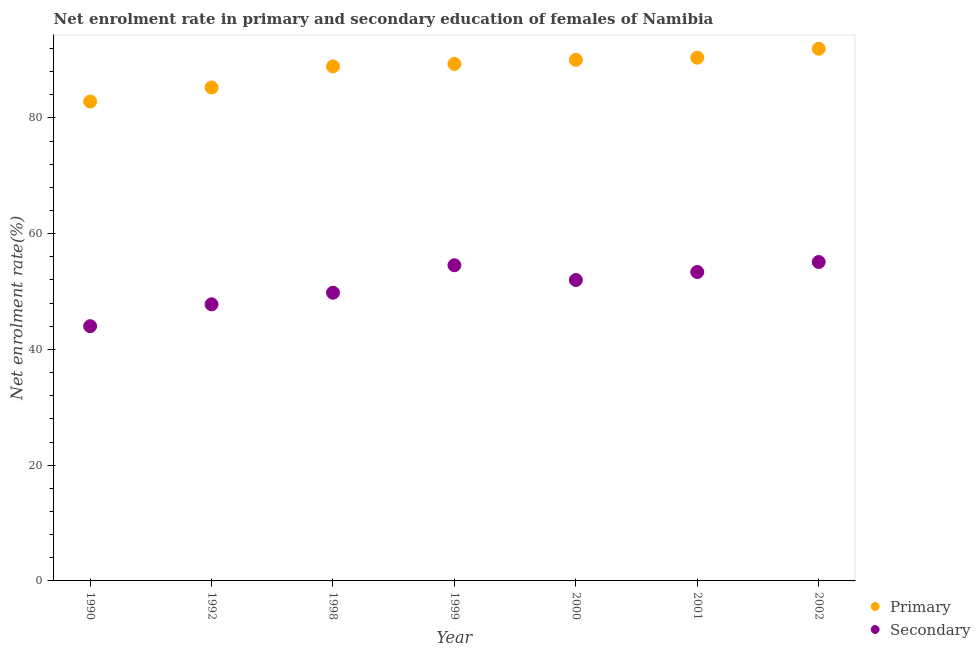How many different coloured dotlines are there?
Keep it short and to the point. 2. Is the number of dotlines equal to the number of legend labels?
Offer a terse response. Yes. What is the enrollment rate in secondary education in 2000?
Offer a terse response. 51.99. Across all years, what is the maximum enrollment rate in secondary education?
Your answer should be very brief. 55.1. Across all years, what is the minimum enrollment rate in secondary education?
Offer a very short reply. 44.01. In which year was the enrollment rate in primary education minimum?
Your answer should be very brief. 1990. What is the total enrollment rate in secondary education in the graph?
Offer a very short reply. 356.61. What is the difference between the enrollment rate in primary education in 1998 and that in 2001?
Make the answer very short. -1.5. What is the difference between the enrollment rate in secondary education in 1999 and the enrollment rate in primary education in 1998?
Provide a succinct answer. -34.35. What is the average enrollment rate in primary education per year?
Offer a very short reply. 88.38. In the year 1990, what is the difference between the enrollment rate in secondary education and enrollment rate in primary education?
Keep it short and to the point. -38.82. In how many years, is the enrollment rate in secondary education greater than 24 %?
Make the answer very short. 7. What is the ratio of the enrollment rate in secondary education in 2001 to that in 2002?
Ensure brevity in your answer.  0.97. Is the enrollment rate in secondary education in 1990 less than that in 2000?
Keep it short and to the point. Yes. Is the difference between the enrollment rate in secondary education in 2000 and 2001 greater than the difference between the enrollment rate in primary education in 2000 and 2001?
Ensure brevity in your answer.  No. What is the difference between the highest and the second highest enrollment rate in secondary education?
Make the answer very short. 0.56. What is the difference between the highest and the lowest enrollment rate in secondary education?
Your answer should be compact. 11.09. Does the enrollment rate in secondary education monotonically increase over the years?
Provide a succinct answer. No. How many dotlines are there?
Provide a short and direct response. 2. How many years are there in the graph?
Ensure brevity in your answer.  7. What is the difference between two consecutive major ticks on the Y-axis?
Provide a succinct answer. 20. Are the values on the major ticks of Y-axis written in scientific E-notation?
Offer a terse response. No. Does the graph contain grids?
Your answer should be compact. No. Where does the legend appear in the graph?
Your answer should be compact. Bottom right. How many legend labels are there?
Make the answer very short. 2. What is the title of the graph?
Give a very brief answer. Net enrolment rate in primary and secondary education of females of Namibia. What is the label or title of the X-axis?
Offer a terse response. Year. What is the label or title of the Y-axis?
Your response must be concise. Net enrolment rate(%). What is the Net enrolment rate(%) of Primary in 1990?
Offer a very short reply. 82.83. What is the Net enrolment rate(%) of Secondary in 1990?
Your response must be concise. 44.01. What is the Net enrolment rate(%) of Primary in 1992?
Offer a very short reply. 85.25. What is the Net enrolment rate(%) of Secondary in 1992?
Keep it short and to the point. 47.79. What is the Net enrolment rate(%) of Primary in 1998?
Provide a short and direct response. 88.89. What is the Net enrolment rate(%) in Secondary in 1998?
Provide a succinct answer. 49.79. What is the Net enrolment rate(%) in Primary in 1999?
Your answer should be compact. 89.32. What is the Net enrolment rate(%) of Secondary in 1999?
Provide a short and direct response. 54.54. What is the Net enrolment rate(%) in Primary in 2000?
Provide a short and direct response. 90.03. What is the Net enrolment rate(%) in Secondary in 2000?
Make the answer very short. 51.99. What is the Net enrolment rate(%) of Primary in 2001?
Your answer should be compact. 90.4. What is the Net enrolment rate(%) of Secondary in 2001?
Provide a short and direct response. 53.37. What is the Net enrolment rate(%) of Primary in 2002?
Ensure brevity in your answer.  91.94. What is the Net enrolment rate(%) of Secondary in 2002?
Give a very brief answer. 55.1. Across all years, what is the maximum Net enrolment rate(%) of Primary?
Make the answer very short. 91.94. Across all years, what is the maximum Net enrolment rate(%) in Secondary?
Offer a very short reply. 55.1. Across all years, what is the minimum Net enrolment rate(%) of Primary?
Your answer should be compact. 82.83. Across all years, what is the minimum Net enrolment rate(%) of Secondary?
Offer a very short reply. 44.01. What is the total Net enrolment rate(%) of Primary in the graph?
Your answer should be very brief. 618.66. What is the total Net enrolment rate(%) in Secondary in the graph?
Your answer should be very brief. 356.61. What is the difference between the Net enrolment rate(%) of Primary in 1990 and that in 1992?
Your answer should be very brief. -2.42. What is the difference between the Net enrolment rate(%) in Secondary in 1990 and that in 1992?
Make the answer very short. -3.78. What is the difference between the Net enrolment rate(%) of Primary in 1990 and that in 1998?
Provide a succinct answer. -6.06. What is the difference between the Net enrolment rate(%) of Secondary in 1990 and that in 1998?
Provide a short and direct response. -5.78. What is the difference between the Net enrolment rate(%) in Primary in 1990 and that in 1999?
Provide a succinct answer. -6.49. What is the difference between the Net enrolment rate(%) of Secondary in 1990 and that in 1999?
Your answer should be very brief. -10.53. What is the difference between the Net enrolment rate(%) of Primary in 1990 and that in 2000?
Give a very brief answer. -7.2. What is the difference between the Net enrolment rate(%) of Secondary in 1990 and that in 2000?
Ensure brevity in your answer.  -7.98. What is the difference between the Net enrolment rate(%) of Primary in 1990 and that in 2001?
Your response must be concise. -7.57. What is the difference between the Net enrolment rate(%) of Secondary in 1990 and that in 2001?
Offer a very short reply. -9.36. What is the difference between the Net enrolment rate(%) of Primary in 1990 and that in 2002?
Provide a succinct answer. -9.12. What is the difference between the Net enrolment rate(%) in Secondary in 1990 and that in 2002?
Make the answer very short. -11.09. What is the difference between the Net enrolment rate(%) of Primary in 1992 and that in 1998?
Provide a succinct answer. -3.64. What is the difference between the Net enrolment rate(%) in Secondary in 1992 and that in 1998?
Your answer should be very brief. -2. What is the difference between the Net enrolment rate(%) in Primary in 1992 and that in 1999?
Provide a short and direct response. -4.07. What is the difference between the Net enrolment rate(%) of Secondary in 1992 and that in 1999?
Your response must be concise. -6.75. What is the difference between the Net enrolment rate(%) in Primary in 1992 and that in 2000?
Offer a terse response. -4.78. What is the difference between the Net enrolment rate(%) of Secondary in 1992 and that in 2000?
Give a very brief answer. -4.2. What is the difference between the Net enrolment rate(%) of Primary in 1992 and that in 2001?
Offer a very short reply. -5.15. What is the difference between the Net enrolment rate(%) of Secondary in 1992 and that in 2001?
Your response must be concise. -5.58. What is the difference between the Net enrolment rate(%) of Primary in 1992 and that in 2002?
Ensure brevity in your answer.  -6.69. What is the difference between the Net enrolment rate(%) in Secondary in 1992 and that in 2002?
Give a very brief answer. -7.31. What is the difference between the Net enrolment rate(%) of Primary in 1998 and that in 1999?
Offer a terse response. -0.43. What is the difference between the Net enrolment rate(%) in Secondary in 1998 and that in 1999?
Offer a terse response. -4.75. What is the difference between the Net enrolment rate(%) of Primary in 1998 and that in 2000?
Offer a very short reply. -1.13. What is the difference between the Net enrolment rate(%) of Secondary in 1998 and that in 2000?
Keep it short and to the point. -2.2. What is the difference between the Net enrolment rate(%) in Primary in 1998 and that in 2001?
Your response must be concise. -1.5. What is the difference between the Net enrolment rate(%) in Secondary in 1998 and that in 2001?
Offer a very short reply. -3.58. What is the difference between the Net enrolment rate(%) in Primary in 1998 and that in 2002?
Offer a very short reply. -3.05. What is the difference between the Net enrolment rate(%) of Secondary in 1998 and that in 2002?
Your answer should be very brief. -5.31. What is the difference between the Net enrolment rate(%) of Primary in 1999 and that in 2000?
Provide a succinct answer. -0.7. What is the difference between the Net enrolment rate(%) of Secondary in 1999 and that in 2000?
Provide a short and direct response. 2.55. What is the difference between the Net enrolment rate(%) of Primary in 1999 and that in 2001?
Ensure brevity in your answer.  -1.08. What is the difference between the Net enrolment rate(%) in Secondary in 1999 and that in 2001?
Your answer should be compact. 1.17. What is the difference between the Net enrolment rate(%) of Primary in 1999 and that in 2002?
Make the answer very short. -2.62. What is the difference between the Net enrolment rate(%) in Secondary in 1999 and that in 2002?
Your answer should be very brief. -0.56. What is the difference between the Net enrolment rate(%) of Primary in 2000 and that in 2001?
Your answer should be very brief. -0.37. What is the difference between the Net enrolment rate(%) of Secondary in 2000 and that in 2001?
Provide a succinct answer. -1.38. What is the difference between the Net enrolment rate(%) of Primary in 2000 and that in 2002?
Your answer should be compact. -1.92. What is the difference between the Net enrolment rate(%) of Secondary in 2000 and that in 2002?
Give a very brief answer. -3.11. What is the difference between the Net enrolment rate(%) in Primary in 2001 and that in 2002?
Ensure brevity in your answer.  -1.55. What is the difference between the Net enrolment rate(%) of Secondary in 2001 and that in 2002?
Provide a short and direct response. -1.73. What is the difference between the Net enrolment rate(%) of Primary in 1990 and the Net enrolment rate(%) of Secondary in 1992?
Give a very brief answer. 35.04. What is the difference between the Net enrolment rate(%) of Primary in 1990 and the Net enrolment rate(%) of Secondary in 1998?
Provide a short and direct response. 33.03. What is the difference between the Net enrolment rate(%) of Primary in 1990 and the Net enrolment rate(%) of Secondary in 1999?
Keep it short and to the point. 28.29. What is the difference between the Net enrolment rate(%) of Primary in 1990 and the Net enrolment rate(%) of Secondary in 2000?
Offer a very short reply. 30.84. What is the difference between the Net enrolment rate(%) of Primary in 1990 and the Net enrolment rate(%) of Secondary in 2001?
Your answer should be very brief. 29.46. What is the difference between the Net enrolment rate(%) in Primary in 1990 and the Net enrolment rate(%) in Secondary in 2002?
Your answer should be very brief. 27.73. What is the difference between the Net enrolment rate(%) in Primary in 1992 and the Net enrolment rate(%) in Secondary in 1998?
Offer a very short reply. 35.46. What is the difference between the Net enrolment rate(%) in Primary in 1992 and the Net enrolment rate(%) in Secondary in 1999?
Your response must be concise. 30.71. What is the difference between the Net enrolment rate(%) of Primary in 1992 and the Net enrolment rate(%) of Secondary in 2000?
Provide a succinct answer. 33.26. What is the difference between the Net enrolment rate(%) in Primary in 1992 and the Net enrolment rate(%) in Secondary in 2001?
Give a very brief answer. 31.88. What is the difference between the Net enrolment rate(%) of Primary in 1992 and the Net enrolment rate(%) of Secondary in 2002?
Provide a succinct answer. 30.15. What is the difference between the Net enrolment rate(%) of Primary in 1998 and the Net enrolment rate(%) of Secondary in 1999?
Give a very brief answer. 34.35. What is the difference between the Net enrolment rate(%) of Primary in 1998 and the Net enrolment rate(%) of Secondary in 2000?
Provide a short and direct response. 36.9. What is the difference between the Net enrolment rate(%) of Primary in 1998 and the Net enrolment rate(%) of Secondary in 2001?
Provide a short and direct response. 35.52. What is the difference between the Net enrolment rate(%) in Primary in 1998 and the Net enrolment rate(%) in Secondary in 2002?
Give a very brief answer. 33.79. What is the difference between the Net enrolment rate(%) of Primary in 1999 and the Net enrolment rate(%) of Secondary in 2000?
Offer a very short reply. 37.33. What is the difference between the Net enrolment rate(%) in Primary in 1999 and the Net enrolment rate(%) in Secondary in 2001?
Offer a terse response. 35.95. What is the difference between the Net enrolment rate(%) in Primary in 1999 and the Net enrolment rate(%) in Secondary in 2002?
Ensure brevity in your answer.  34.22. What is the difference between the Net enrolment rate(%) in Primary in 2000 and the Net enrolment rate(%) in Secondary in 2001?
Make the answer very short. 36.66. What is the difference between the Net enrolment rate(%) of Primary in 2000 and the Net enrolment rate(%) of Secondary in 2002?
Make the answer very short. 34.92. What is the difference between the Net enrolment rate(%) in Primary in 2001 and the Net enrolment rate(%) in Secondary in 2002?
Offer a terse response. 35.29. What is the average Net enrolment rate(%) of Primary per year?
Make the answer very short. 88.38. What is the average Net enrolment rate(%) in Secondary per year?
Your response must be concise. 50.94. In the year 1990, what is the difference between the Net enrolment rate(%) of Primary and Net enrolment rate(%) of Secondary?
Offer a terse response. 38.82. In the year 1992, what is the difference between the Net enrolment rate(%) in Primary and Net enrolment rate(%) in Secondary?
Offer a terse response. 37.46. In the year 1998, what is the difference between the Net enrolment rate(%) in Primary and Net enrolment rate(%) in Secondary?
Keep it short and to the point. 39.1. In the year 1999, what is the difference between the Net enrolment rate(%) of Primary and Net enrolment rate(%) of Secondary?
Keep it short and to the point. 34.78. In the year 2000, what is the difference between the Net enrolment rate(%) in Primary and Net enrolment rate(%) in Secondary?
Your answer should be compact. 38.03. In the year 2001, what is the difference between the Net enrolment rate(%) of Primary and Net enrolment rate(%) of Secondary?
Your answer should be very brief. 37.03. In the year 2002, what is the difference between the Net enrolment rate(%) of Primary and Net enrolment rate(%) of Secondary?
Offer a very short reply. 36.84. What is the ratio of the Net enrolment rate(%) in Primary in 1990 to that in 1992?
Your response must be concise. 0.97. What is the ratio of the Net enrolment rate(%) of Secondary in 1990 to that in 1992?
Your response must be concise. 0.92. What is the ratio of the Net enrolment rate(%) of Primary in 1990 to that in 1998?
Provide a succinct answer. 0.93. What is the ratio of the Net enrolment rate(%) in Secondary in 1990 to that in 1998?
Your answer should be very brief. 0.88. What is the ratio of the Net enrolment rate(%) in Primary in 1990 to that in 1999?
Your answer should be compact. 0.93. What is the ratio of the Net enrolment rate(%) in Secondary in 1990 to that in 1999?
Make the answer very short. 0.81. What is the ratio of the Net enrolment rate(%) of Primary in 1990 to that in 2000?
Provide a short and direct response. 0.92. What is the ratio of the Net enrolment rate(%) of Secondary in 1990 to that in 2000?
Make the answer very short. 0.85. What is the ratio of the Net enrolment rate(%) in Primary in 1990 to that in 2001?
Offer a very short reply. 0.92. What is the ratio of the Net enrolment rate(%) of Secondary in 1990 to that in 2001?
Keep it short and to the point. 0.82. What is the ratio of the Net enrolment rate(%) in Primary in 1990 to that in 2002?
Offer a very short reply. 0.9. What is the ratio of the Net enrolment rate(%) of Secondary in 1990 to that in 2002?
Keep it short and to the point. 0.8. What is the ratio of the Net enrolment rate(%) of Primary in 1992 to that in 1998?
Keep it short and to the point. 0.96. What is the ratio of the Net enrolment rate(%) of Secondary in 1992 to that in 1998?
Offer a very short reply. 0.96. What is the ratio of the Net enrolment rate(%) in Primary in 1992 to that in 1999?
Offer a terse response. 0.95. What is the ratio of the Net enrolment rate(%) of Secondary in 1992 to that in 1999?
Make the answer very short. 0.88. What is the ratio of the Net enrolment rate(%) of Primary in 1992 to that in 2000?
Your answer should be compact. 0.95. What is the ratio of the Net enrolment rate(%) in Secondary in 1992 to that in 2000?
Offer a very short reply. 0.92. What is the ratio of the Net enrolment rate(%) in Primary in 1992 to that in 2001?
Offer a terse response. 0.94. What is the ratio of the Net enrolment rate(%) of Secondary in 1992 to that in 2001?
Your answer should be compact. 0.9. What is the ratio of the Net enrolment rate(%) in Primary in 1992 to that in 2002?
Give a very brief answer. 0.93. What is the ratio of the Net enrolment rate(%) of Secondary in 1992 to that in 2002?
Your response must be concise. 0.87. What is the ratio of the Net enrolment rate(%) in Primary in 1998 to that in 1999?
Your answer should be compact. 1. What is the ratio of the Net enrolment rate(%) in Primary in 1998 to that in 2000?
Offer a terse response. 0.99. What is the ratio of the Net enrolment rate(%) in Secondary in 1998 to that in 2000?
Offer a very short reply. 0.96. What is the ratio of the Net enrolment rate(%) of Primary in 1998 to that in 2001?
Provide a succinct answer. 0.98. What is the ratio of the Net enrolment rate(%) of Secondary in 1998 to that in 2001?
Your answer should be very brief. 0.93. What is the ratio of the Net enrolment rate(%) of Primary in 1998 to that in 2002?
Your answer should be compact. 0.97. What is the ratio of the Net enrolment rate(%) of Secondary in 1998 to that in 2002?
Give a very brief answer. 0.9. What is the ratio of the Net enrolment rate(%) of Primary in 1999 to that in 2000?
Your answer should be very brief. 0.99. What is the ratio of the Net enrolment rate(%) of Secondary in 1999 to that in 2000?
Make the answer very short. 1.05. What is the ratio of the Net enrolment rate(%) of Secondary in 1999 to that in 2001?
Make the answer very short. 1.02. What is the ratio of the Net enrolment rate(%) in Primary in 1999 to that in 2002?
Your answer should be very brief. 0.97. What is the ratio of the Net enrolment rate(%) of Secondary in 2000 to that in 2001?
Your answer should be compact. 0.97. What is the ratio of the Net enrolment rate(%) in Primary in 2000 to that in 2002?
Your answer should be compact. 0.98. What is the ratio of the Net enrolment rate(%) in Secondary in 2000 to that in 2002?
Offer a very short reply. 0.94. What is the ratio of the Net enrolment rate(%) of Primary in 2001 to that in 2002?
Keep it short and to the point. 0.98. What is the ratio of the Net enrolment rate(%) in Secondary in 2001 to that in 2002?
Provide a short and direct response. 0.97. What is the difference between the highest and the second highest Net enrolment rate(%) of Primary?
Provide a short and direct response. 1.55. What is the difference between the highest and the second highest Net enrolment rate(%) of Secondary?
Offer a very short reply. 0.56. What is the difference between the highest and the lowest Net enrolment rate(%) in Primary?
Ensure brevity in your answer.  9.12. What is the difference between the highest and the lowest Net enrolment rate(%) of Secondary?
Provide a succinct answer. 11.09. 